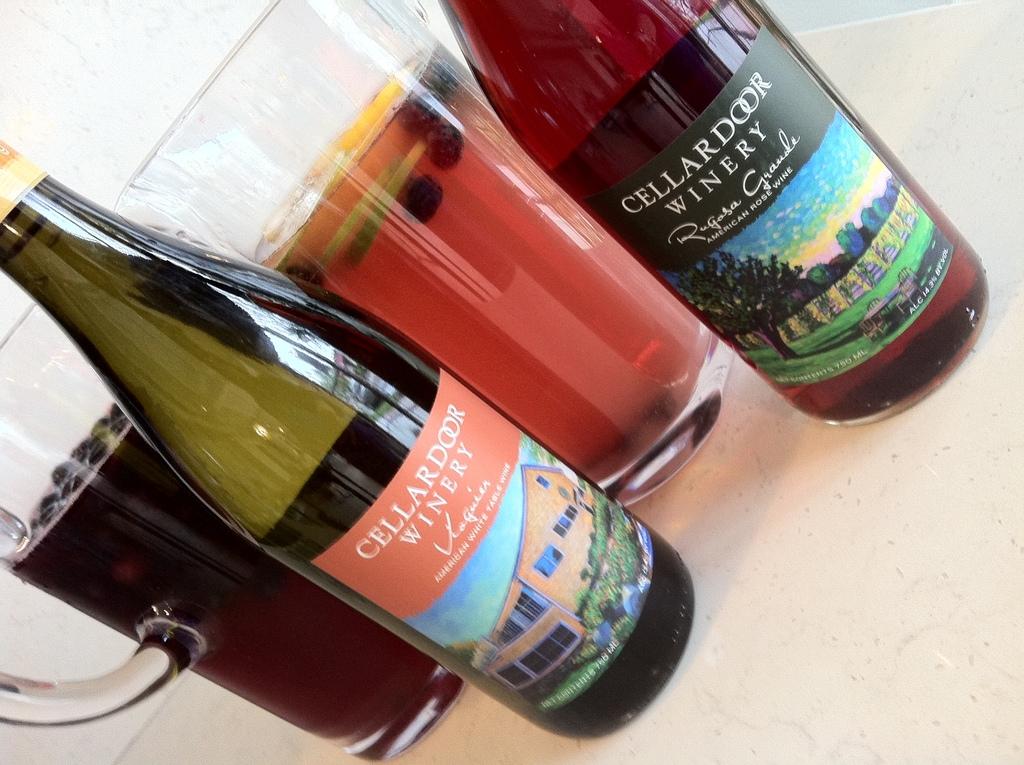What winery made this wine?
Provide a short and direct response. Cellardoor. Which country is the winery in?
Make the answer very short. America. 